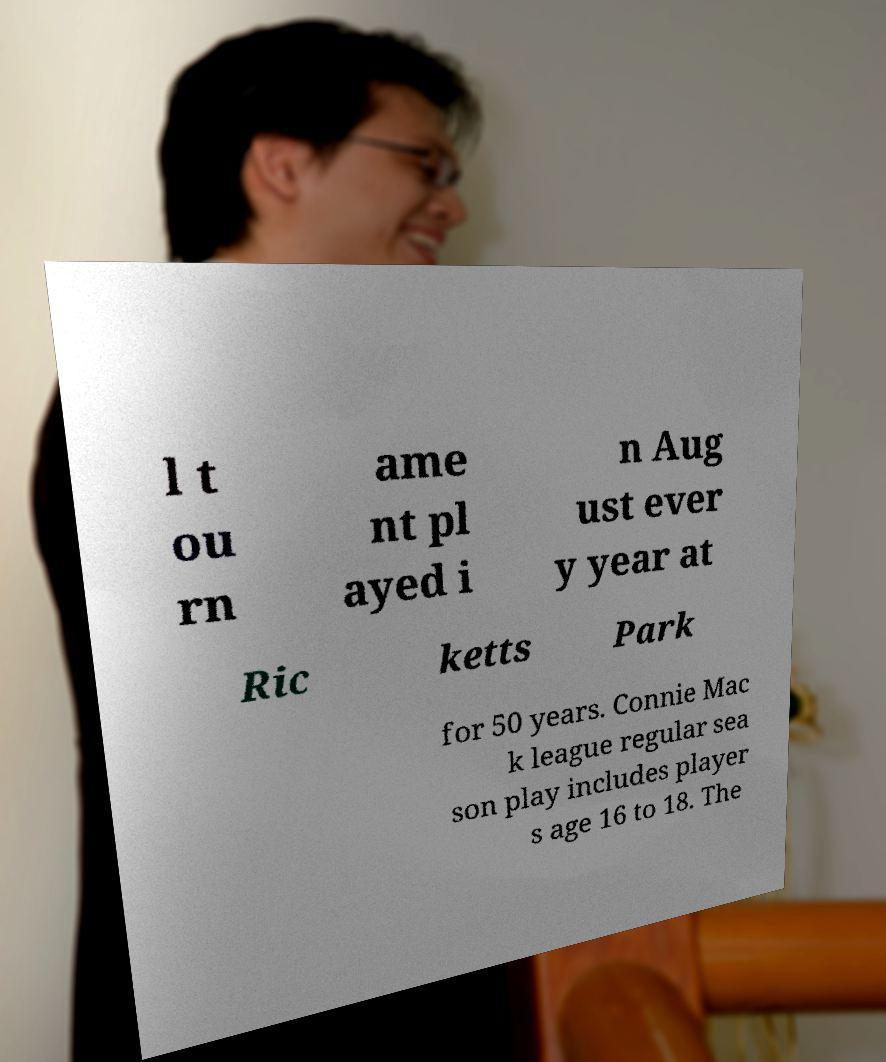I need the written content from this picture converted into text. Can you do that? l t ou rn ame nt pl ayed i n Aug ust ever y year at Ric ketts Park for 50 years. Connie Mac k league regular sea son play includes player s age 16 to 18. The 